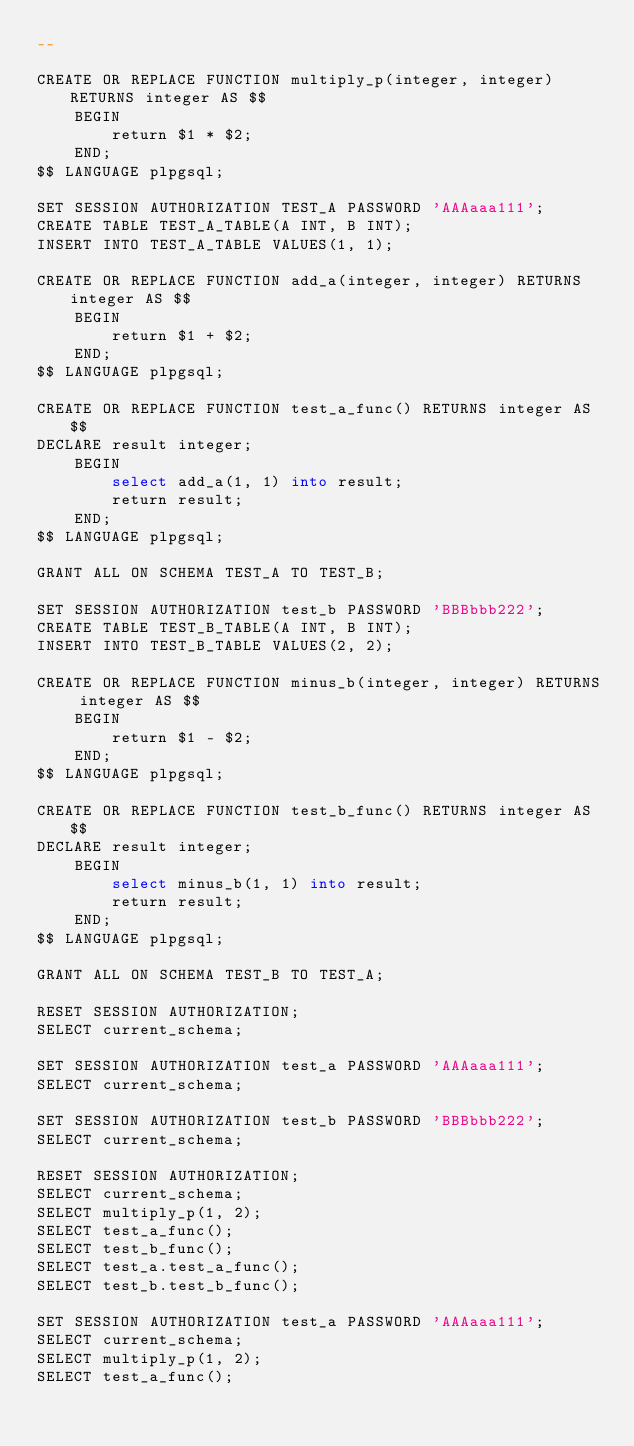<code> <loc_0><loc_0><loc_500><loc_500><_SQL_>--

CREATE OR REPLACE FUNCTION multiply_p(integer, integer) RETURNS integer AS $$
    BEGIN
        return $1 * $2;
    END;
$$ LANGUAGE plpgsql;

SET SESSION AUTHORIZATION TEST_A PASSWORD 'AAAaaa111';
CREATE TABLE TEST_A_TABLE(A INT, B INT);
INSERT INTO TEST_A_TABLE VALUES(1, 1);

CREATE OR REPLACE FUNCTION add_a(integer, integer) RETURNS integer AS $$
    BEGIN
        return $1 + $2;
    END;
$$ LANGUAGE plpgsql;

CREATE OR REPLACE FUNCTION test_a_func() RETURNS integer AS $$
DECLARE result integer;
    BEGIN
        select add_a(1, 1) into result;
        return result;
    END;
$$ LANGUAGE plpgsql;

GRANT ALL ON SCHEMA TEST_A TO TEST_B;

SET SESSION AUTHORIZATION test_b PASSWORD 'BBBbbb222';
CREATE TABLE TEST_B_TABLE(A INT, B INT);
INSERT INTO TEST_B_TABLE VALUES(2, 2);

CREATE OR REPLACE FUNCTION minus_b(integer, integer) RETURNS integer AS $$
    BEGIN
        return $1 - $2;
    END;
$$ LANGUAGE plpgsql;

CREATE OR REPLACE FUNCTION test_b_func() RETURNS integer AS $$
DECLARE result integer;
    BEGIN
        select minus_b(1, 1) into result;
        return result;
    END;
$$ LANGUAGE plpgsql;

GRANT ALL ON SCHEMA TEST_B TO TEST_A;

RESET SESSION AUTHORIZATION;
SELECT current_schema;

SET SESSION AUTHORIZATION test_a PASSWORD 'AAAaaa111';
SELECT current_schema;

SET SESSION AUTHORIZATION test_b PASSWORD 'BBBbbb222';
SELECT current_schema;

RESET SESSION AUTHORIZATION;
SELECT current_schema;
SELECT multiply_p(1, 2);
SELECT test_a_func();
SELECT test_b_func();
SELECT test_a.test_a_func();
SELECT test_b.test_b_func();

SET SESSION AUTHORIZATION test_a PASSWORD 'AAAaaa111';
SELECT current_schema;
SELECT multiply_p(1, 2);
SELECT test_a_func();</code> 